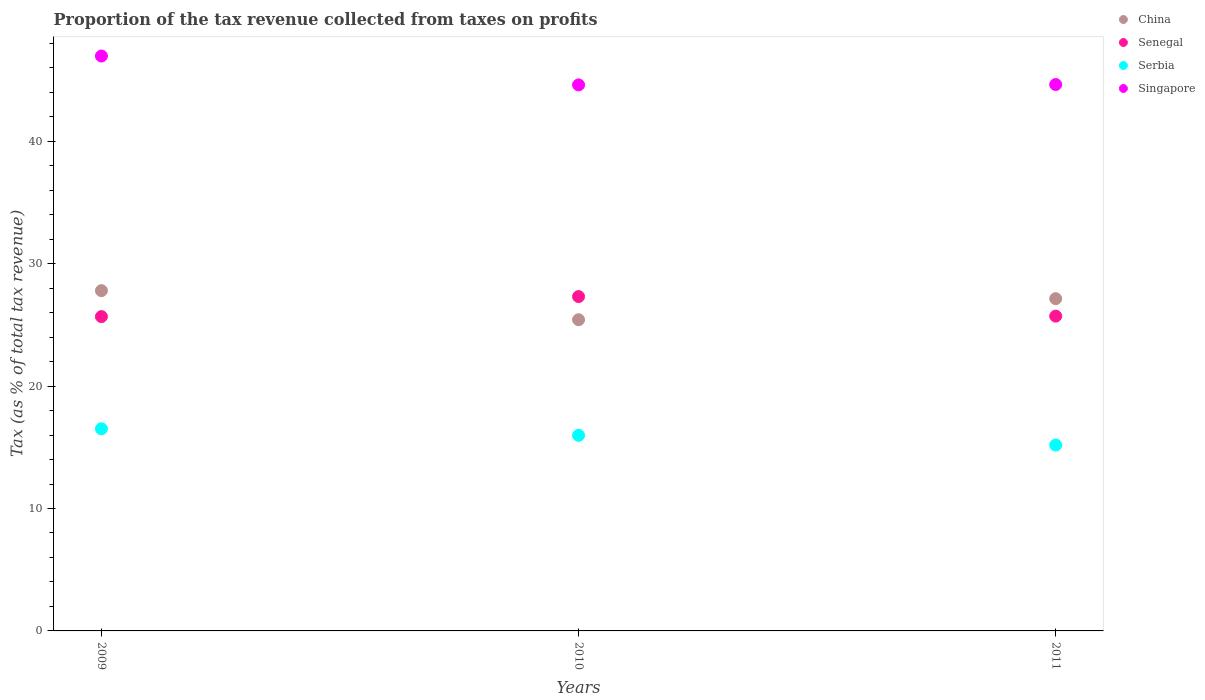Is the number of dotlines equal to the number of legend labels?
Provide a short and direct response. Yes. What is the proportion of the tax revenue collected in China in 2010?
Provide a short and direct response. 25.42. Across all years, what is the maximum proportion of the tax revenue collected in China?
Ensure brevity in your answer.  27.79. Across all years, what is the minimum proportion of the tax revenue collected in Serbia?
Give a very brief answer. 15.18. What is the total proportion of the tax revenue collected in Senegal in the graph?
Your response must be concise. 78.69. What is the difference between the proportion of the tax revenue collected in Singapore in 2009 and that in 2011?
Make the answer very short. 2.33. What is the difference between the proportion of the tax revenue collected in Singapore in 2011 and the proportion of the tax revenue collected in Senegal in 2010?
Provide a short and direct response. 17.32. What is the average proportion of the tax revenue collected in China per year?
Your answer should be compact. 26.78. In the year 2010, what is the difference between the proportion of the tax revenue collected in Serbia and proportion of the tax revenue collected in Senegal?
Make the answer very short. -11.33. What is the ratio of the proportion of the tax revenue collected in Senegal in 2009 to that in 2011?
Your answer should be very brief. 1. Is the proportion of the tax revenue collected in Senegal in 2009 less than that in 2010?
Offer a very short reply. Yes. Is the difference between the proportion of the tax revenue collected in Serbia in 2009 and 2011 greater than the difference between the proportion of the tax revenue collected in Senegal in 2009 and 2011?
Offer a very short reply. Yes. What is the difference between the highest and the second highest proportion of the tax revenue collected in Singapore?
Ensure brevity in your answer.  2.33. What is the difference between the highest and the lowest proportion of the tax revenue collected in Singapore?
Ensure brevity in your answer.  2.36. In how many years, is the proportion of the tax revenue collected in Senegal greater than the average proportion of the tax revenue collected in Senegal taken over all years?
Offer a terse response. 1. Is the sum of the proportion of the tax revenue collected in China in 2010 and 2011 greater than the maximum proportion of the tax revenue collected in Serbia across all years?
Your answer should be compact. Yes. Is it the case that in every year, the sum of the proportion of the tax revenue collected in Senegal and proportion of the tax revenue collected in China  is greater than the proportion of the tax revenue collected in Singapore?
Ensure brevity in your answer.  Yes. Is the proportion of the tax revenue collected in Senegal strictly greater than the proportion of the tax revenue collected in China over the years?
Your response must be concise. No. Is the proportion of the tax revenue collected in Singapore strictly less than the proportion of the tax revenue collected in Serbia over the years?
Provide a succinct answer. No. How many dotlines are there?
Offer a terse response. 4. How many years are there in the graph?
Make the answer very short. 3. Are the values on the major ticks of Y-axis written in scientific E-notation?
Keep it short and to the point. No. Does the graph contain any zero values?
Give a very brief answer. No. How many legend labels are there?
Keep it short and to the point. 4. How are the legend labels stacked?
Provide a succinct answer. Vertical. What is the title of the graph?
Ensure brevity in your answer.  Proportion of the tax revenue collected from taxes on profits. What is the label or title of the X-axis?
Give a very brief answer. Years. What is the label or title of the Y-axis?
Provide a short and direct response. Tax (as % of total tax revenue). What is the Tax (as % of total tax revenue) of China in 2009?
Provide a succinct answer. 27.79. What is the Tax (as % of total tax revenue) in Senegal in 2009?
Your answer should be compact. 25.67. What is the Tax (as % of total tax revenue) of Serbia in 2009?
Your answer should be compact. 16.51. What is the Tax (as % of total tax revenue) of Singapore in 2009?
Keep it short and to the point. 46.96. What is the Tax (as % of total tax revenue) in China in 2010?
Offer a terse response. 25.42. What is the Tax (as % of total tax revenue) of Senegal in 2010?
Ensure brevity in your answer.  27.31. What is the Tax (as % of total tax revenue) in Serbia in 2010?
Your response must be concise. 15.98. What is the Tax (as % of total tax revenue) of Singapore in 2010?
Ensure brevity in your answer.  44.6. What is the Tax (as % of total tax revenue) of China in 2011?
Your answer should be compact. 27.14. What is the Tax (as % of total tax revenue) in Senegal in 2011?
Provide a succinct answer. 25.71. What is the Tax (as % of total tax revenue) in Serbia in 2011?
Provide a succinct answer. 15.18. What is the Tax (as % of total tax revenue) in Singapore in 2011?
Make the answer very short. 44.63. Across all years, what is the maximum Tax (as % of total tax revenue) of China?
Provide a succinct answer. 27.79. Across all years, what is the maximum Tax (as % of total tax revenue) of Senegal?
Keep it short and to the point. 27.31. Across all years, what is the maximum Tax (as % of total tax revenue) in Serbia?
Your response must be concise. 16.51. Across all years, what is the maximum Tax (as % of total tax revenue) of Singapore?
Provide a short and direct response. 46.96. Across all years, what is the minimum Tax (as % of total tax revenue) in China?
Your answer should be compact. 25.42. Across all years, what is the minimum Tax (as % of total tax revenue) of Senegal?
Your answer should be very brief. 25.67. Across all years, what is the minimum Tax (as % of total tax revenue) of Serbia?
Make the answer very short. 15.18. Across all years, what is the minimum Tax (as % of total tax revenue) in Singapore?
Your answer should be compact. 44.6. What is the total Tax (as % of total tax revenue) of China in the graph?
Provide a short and direct response. 80.35. What is the total Tax (as % of total tax revenue) in Senegal in the graph?
Your response must be concise. 78.69. What is the total Tax (as % of total tax revenue) in Serbia in the graph?
Provide a succinct answer. 47.67. What is the total Tax (as % of total tax revenue) of Singapore in the graph?
Your answer should be very brief. 136.19. What is the difference between the Tax (as % of total tax revenue) in China in 2009 and that in 2010?
Your answer should be compact. 2.37. What is the difference between the Tax (as % of total tax revenue) of Senegal in 2009 and that in 2010?
Make the answer very short. -1.64. What is the difference between the Tax (as % of total tax revenue) in Serbia in 2009 and that in 2010?
Give a very brief answer. 0.53. What is the difference between the Tax (as % of total tax revenue) in Singapore in 2009 and that in 2010?
Provide a succinct answer. 2.36. What is the difference between the Tax (as % of total tax revenue) of China in 2009 and that in 2011?
Provide a short and direct response. 0.65. What is the difference between the Tax (as % of total tax revenue) of Senegal in 2009 and that in 2011?
Your answer should be very brief. -0.04. What is the difference between the Tax (as % of total tax revenue) of Serbia in 2009 and that in 2011?
Ensure brevity in your answer.  1.33. What is the difference between the Tax (as % of total tax revenue) of Singapore in 2009 and that in 2011?
Your answer should be very brief. 2.33. What is the difference between the Tax (as % of total tax revenue) of China in 2010 and that in 2011?
Ensure brevity in your answer.  -1.72. What is the difference between the Tax (as % of total tax revenue) of Senegal in 2010 and that in 2011?
Your response must be concise. 1.6. What is the difference between the Tax (as % of total tax revenue) in Serbia in 2010 and that in 2011?
Give a very brief answer. 0.8. What is the difference between the Tax (as % of total tax revenue) of Singapore in 2010 and that in 2011?
Your response must be concise. -0.03. What is the difference between the Tax (as % of total tax revenue) in China in 2009 and the Tax (as % of total tax revenue) in Senegal in 2010?
Offer a very short reply. 0.48. What is the difference between the Tax (as % of total tax revenue) of China in 2009 and the Tax (as % of total tax revenue) of Serbia in 2010?
Give a very brief answer. 11.81. What is the difference between the Tax (as % of total tax revenue) in China in 2009 and the Tax (as % of total tax revenue) in Singapore in 2010?
Your response must be concise. -16.81. What is the difference between the Tax (as % of total tax revenue) in Senegal in 2009 and the Tax (as % of total tax revenue) in Serbia in 2010?
Give a very brief answer. 9.7. What is the difference between the Tax (as % of total tax revenue) in Senegal in 2009 and the Tax (as % of total tax revenue) in Singapore in 2010?
Your answer should be very brief. -18.93. What is the difference between the Tax (as % of total tax revenue) in Serbia in 2009 and the Tax (as % of total tax revenue) in Singapore in 2010?
Provide a short and direct response. -28.09. What is the difference between the Tax (as % of total tax revenue) in China in 2009 and the Tax (as % of total tax revenue) in Senegal in 2011?
Keep it short and to the point. 2.08. What is the difference between the Tax (as % of total tax revenue) in China in 2009 and the Tax (as % of total tax revenue) in Serbia in 2011?
Keep it short and to the point. 12.61. What is the difference between the Tax (as % of total tax revenue) in China in 2009 and the Tax (as % of total tax revenue) in Singapore in 2011?
Your answer should be very brief. -16.84. What is the difference between the Tax (as % of total tax revenue) of Senegal in 2009 and the Tax (as % of total tax revenue) of Serbia in 2011?
Keep it short and to the point. 10.49. What is the difference between the Tax (as % of total tax revenue) of Senegal in 2009 and the Tax (as % of total tax revenue) of Singapore in 2011?
Your response must be concise. -18.96. What is the difference between the Tax (as % of total tax revenue) of Serbia in 2009 and the Tax (as % of total tax revenue) of Singapore in 2011?
Provide a short and direct response. -28.12. What is the difference between the Tax (as % of total tax revenue) of China in 2010 and the Tax (as % of total tax revenue) of Senegal in 2011?
Offer a terse response. -0.29. What is the difference between the Tax (as % of total tax revenue) in China in 2010 and the Tax (as % of total tax revenue) in Serbia in 2011?
Your response must be concise. 10.24. What is the difference between the Tax (as % of total tax revenue) of China in 2010 and the Tax (as % of total tax revenue) of Singapore in 2011?
Offer a terse response. -19.21. What is the difference between the Tax (as % of total tax revenue) of Senegal in 2010 and the Tax (as % of total tax revenue) of Serbia in 2011?
Your answer should be very brief. 12.13. What is the difference between the Tax (as % of total tax revenue) in Senegal in 2010 and the Tax (as % of total tax revenue) in Singapore in 2011?
Keep it short and to the point. -17.32. What is the difference between the Tax (as % of total tax revenue) in Serbia in 2010 and the Tax (as % of total tax revenue) in Singapore in 2011?
Your answer should be compact. -28.65. What is the average Tax (as % of total tax revenue) of China per year?
Provide a short and direct response. 26.78. What is the average Tax (as % of total tax revenue) of Senegal per year?
Ensure brevity in your answer.  26.23. What is the average Tax (as % of total tax revenue) of Serbia per year?
Keep it short and to the point. 15.89. What is the average Tax (as % of total tax revenue) of Singapore per year?
Your response must be concise. 45.4. In the year 2009, what is the difference between the Tax (as % of total tax revenue) in China and Tax (as % of total tax revenue) in Senegal?
Give a very brief answer. 2.12. In the year 2009, what is the difference between the Tax (as % of total tax revenue) of China and Tax (as % of total tax revenue) of Serbia?
Make the answer very short. 11.28. In the year 2009, what is the difference between the Tax (as % of total tax revenue) of China and Tax (as % of total tax revenue) of Singapore?
Give a very brief answer. -19.17. In the year 2009, what is the difference between the Tax (as % of total tax revenue) in Senegal and Tax (as % of total tax revenue) in Serbia?
Offer a very short reply. 9.16. In the year 2009, what is the difference between the Tax (as % of total tax revenue) in Senegal and Tax (as % of total tax revenue) in Singapore?
Make the answer very short. -21.28. In the year 2009, what is the difference between the Tax (as % of total tax revenue) of Serbia and Tax (as % of total tax revenue) of Singapore?
Offer a very short reply. -30.45. In the year 2010, what is the difference between the Tax (as % of total tax revenue) in China and Tax (as % of total tax revenue) in Senegal?
Offer a very short reply. -1.89. In the year 2010, what is the difference between the Tax (as % of total tax revenue) in China and Tax (as % of total tax revenue) in Serbia?
Make the answer very short. 9.44. In the year 2010, what is the difference between the Tax (as % of total tax revenue) of China and Tax (as % of total tax revenue) of Singapore?
Keep it short and to the point. -19.18. In the year 2010, what is the difference between the Tax (as % of total tax revenue) in Senegal and Tax (as % of total tax revenue) in Serbia?
Make the answer very short. 11.33. In the year 2010, what is the difference between the Tax (as % of total tax revenue) in Senegal and Tax (as % of total tax revenue) in Singapore?
Ensure brevity in your answer.  -17.29. In the year 2010, what is the difference between the Tax (as % of total tax revenue) of Serbia and Tax (as % of total tax revenue) of Singapore?
Provide a short and direct response. -28.62. In the year 2011, what is the difference between the Tax (as % of total tax revenue) of China and Tax (as % of total tax revenue) of Senegal?
Your answer should be very brief. 1.43. In the year 2011, what is the difference between the Tax (as % of total tax revenue) of China and Tax (as % of total tax revenue) of Serbia?
Keep it short and to the point. 11.96. In the year 2011, what is the difference between the Tax (as % of total tax revenue) of China and Tax (as % of total tax revenue) of Singapore?
Your response must be concise. -17.49. In the year 2011, what is the difference between the Tax (as % of total tax revenue) in Senegal and Tax (as % of total tax revenue) in Serbia?
Your response must be concise. 10.53. In the year 2011, what is the difference between the Tax (as % of total tax revenue) of Senegal and Tax (as % of total tax revenue) of Singapore?
Make the answer very short. -18.92. In the year 2011, what is the difference between the Tax (as % of total tax revenue) of Serbia and Tax (as % of total tax revenue) of Singapore?
Provide a succinct answer. -29.45. What is the ratio of the Tax (as % of total tax revenue) of China in 2009 to that in 2010?
Keep it short and to the point. 1.09. What is the ratio of the Tax (as % of total tax revenue) in Senegal in 2009 to that in 2010?
Ensure brevity in your answer.  0.94. What is the ratio of the Tax (as % of total tax revenue) of Serbia in 2009 to that in 2010?
Your answer should be very brief. 1.03. What is the ratio of the Tax (as % of total tax revenue) of Singapore in 2009 to that in 2010?
Offer a terse response. 1.05. What is the ratio of the Tax (as % of total tax revenue) of China in 2009 to that in 2011?
Your response must be concise. 1.02. What is the ratio of the Tax (as % of total tax revenue) of Senegal in 2009 to that in 2011?
Give a very brief answer. 1. What is the ratio of the Tax (as % of total tax revenue) of Serbia in 2009 to that in 2011?
Your response must be concise. 1.09. What is the ratio of the Tax (as % of total tax revenue) of Singapore in 2009 to that in 2011?
Ensure brevity in your answer.  1.05. What is the ratio of the Tax (as % of total tax revenue) of China in 2010 to that in 2011?
Make the answer very short. 0.94. What is the ratio of the Tax (as % of total tax revenue) in Senegal in 2010 to that in 2011?
Your answer should be compact. 1.06. What is the ratio of the Tax (as % of total tax revenue) in Serbia in 2010 to that in 2011?
Your response must be concise. 1.05. What is the ratio of the Tax (as % of total tax revenue) in Singapore in 2010 to that in 2011?
Provide a succinct answer. 1. What is the difference between the highest and the second highest Tax (as % of total tax revenue) of China?
Provide a short and direct response. 0.65. What is the difference between the highest and the second highest Tax (as % of total tax revenue) in Senegal?
Your answer should be very brief. 1.6. What is the difference between the highest and the second highest Tax (as % of total tax revenue) in Serbia?
Your answer should be compact. 0.53. What is the difference between the highest and the second highest Tax (as % of total tax revenue) of Singapore?
Make the answer very short. 2.33. What is the difference between the highest and the lowest Tax (as % of total tax revenue) of China?
Make the answer very short. 2.37. What is the difference between the highest and the lowest Tax (as % of total tax revenue) in Senegal?
Provide a short and direct response. 1.64. What is the difference between the highest and the lowest Tax (as % of total tax revenue) of Serbia?
Your answer should be very brief. 1.33. What is the difference between the highest and the lowest Tax (as % of total tax revenue) in Singapore?
Offer a terse response. 2.36. 